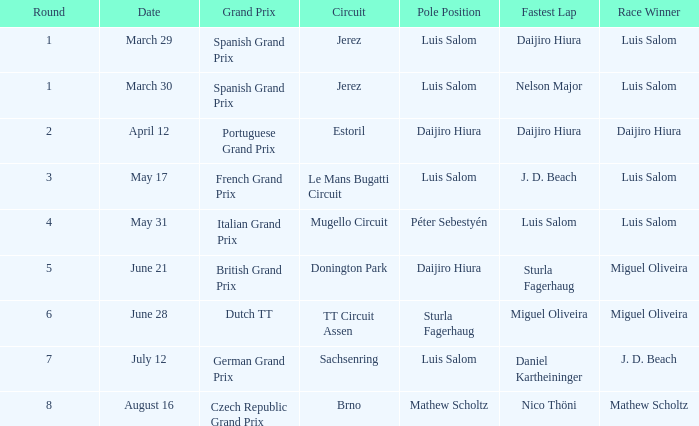Luis Salom had the fastest lap on which circuits?  Mugello Circuit. 